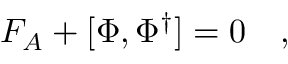<formula> <loc_0><loc_0><loc_500><loc_500>F _ { A } + [ \Phi , \Phi ^ { \dagger } ] = 0 \quad ,</formula> 